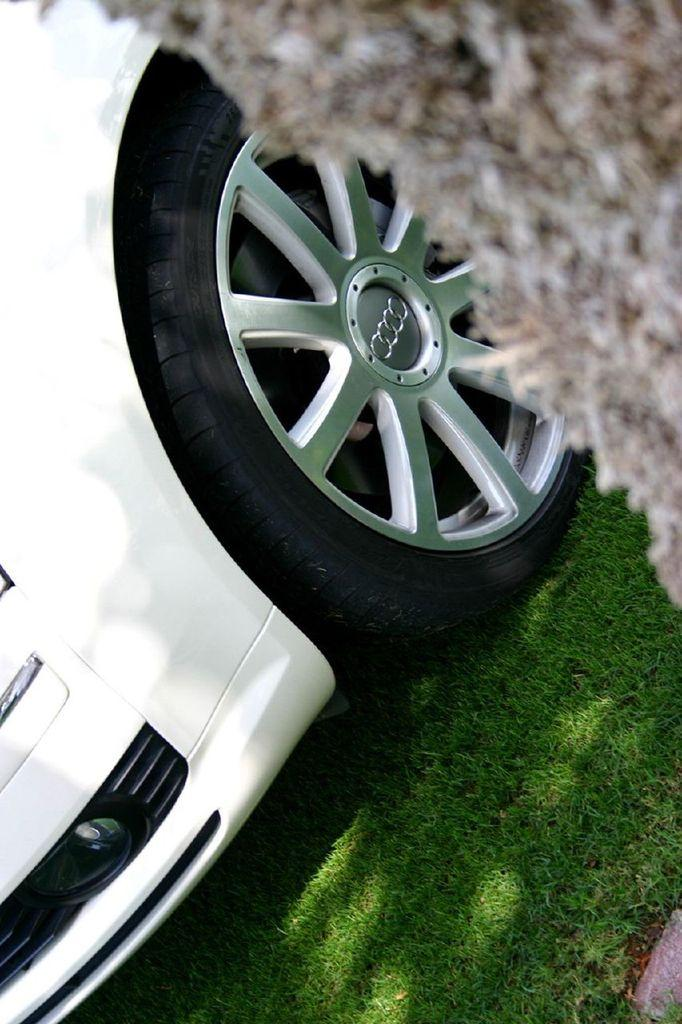What type of vegetation is present on the ground in the image? There is grass on the ground in the image. What is the main subject in the center of the image? There is a car in the center of the image. Can you describe the object visible on the right side of the image? Unfortunately, the provided facts do not give enough information to describe the object on the right side of the image. Is the car sleeping in the image? Cars do not sleep, so this question is not applicable to the image. Can you find a needle in the image? There is no mention of a needle in the provided facts, so it cannot be determined if one is present in the image. 